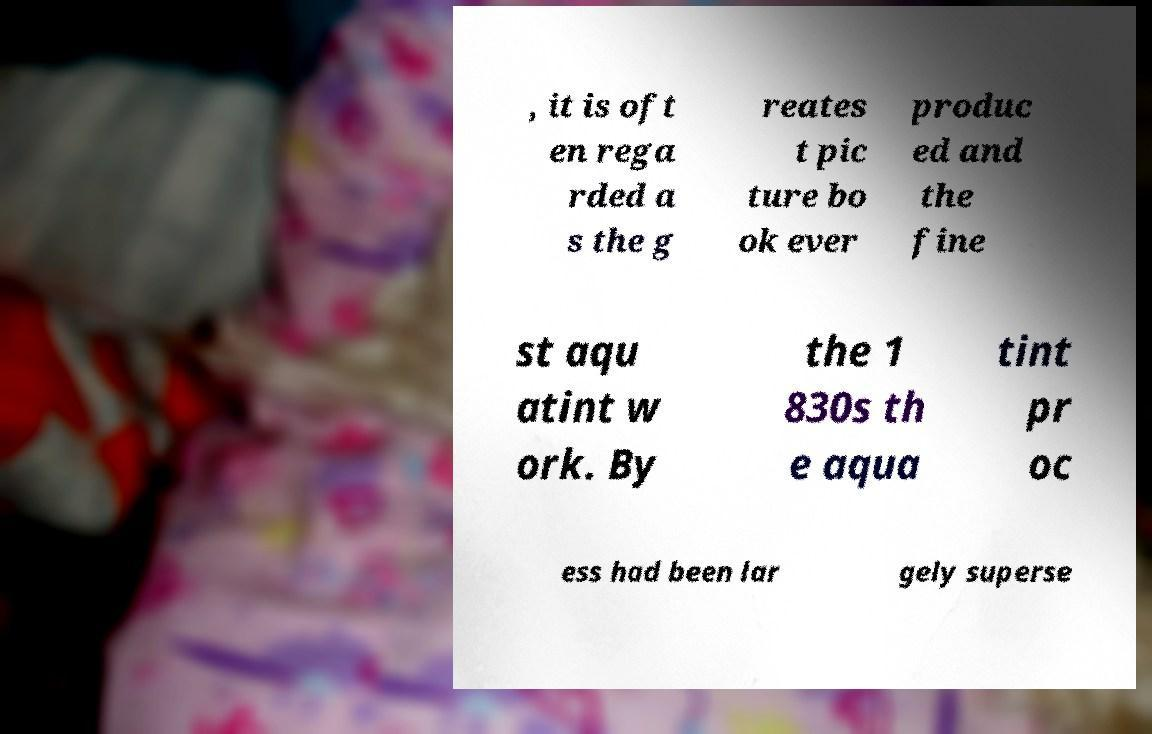Please read and relay the text visible in this image. What does it say? , it is oft en rega rded a s the g reates t pic ture bo ok ever produc ed and the fine st aqu atint w ork. By the 1 830s th e aqua tint pr oc ess had been lar gely superse 